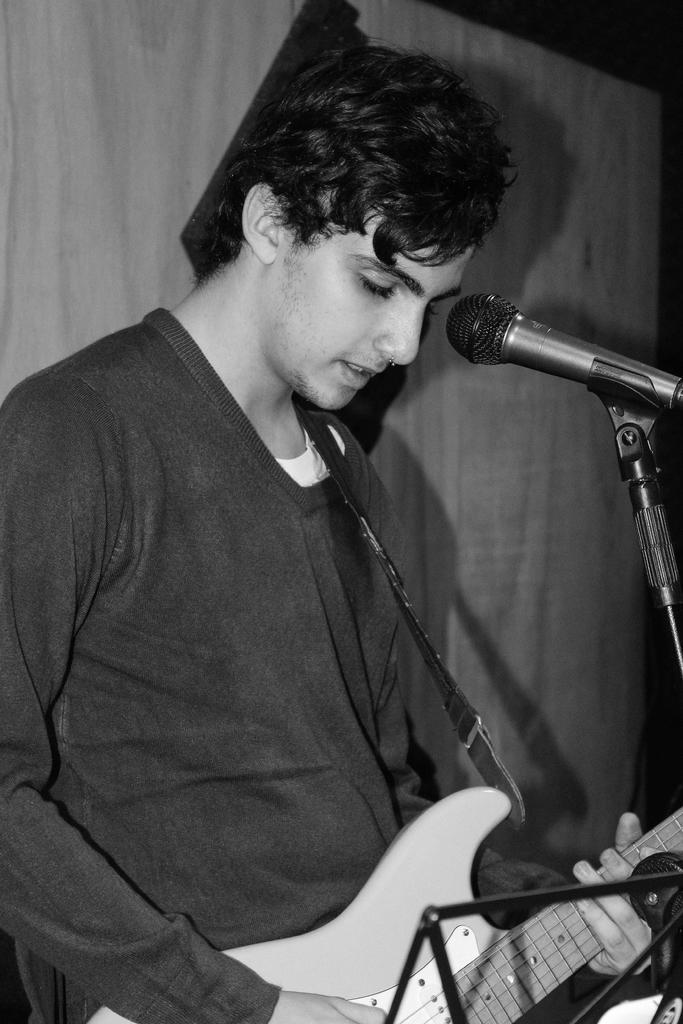Can you describe this image briefly? In this image in the center there is one man who is playing a guitar, in front of him there is one mike on the background there is a wall. 